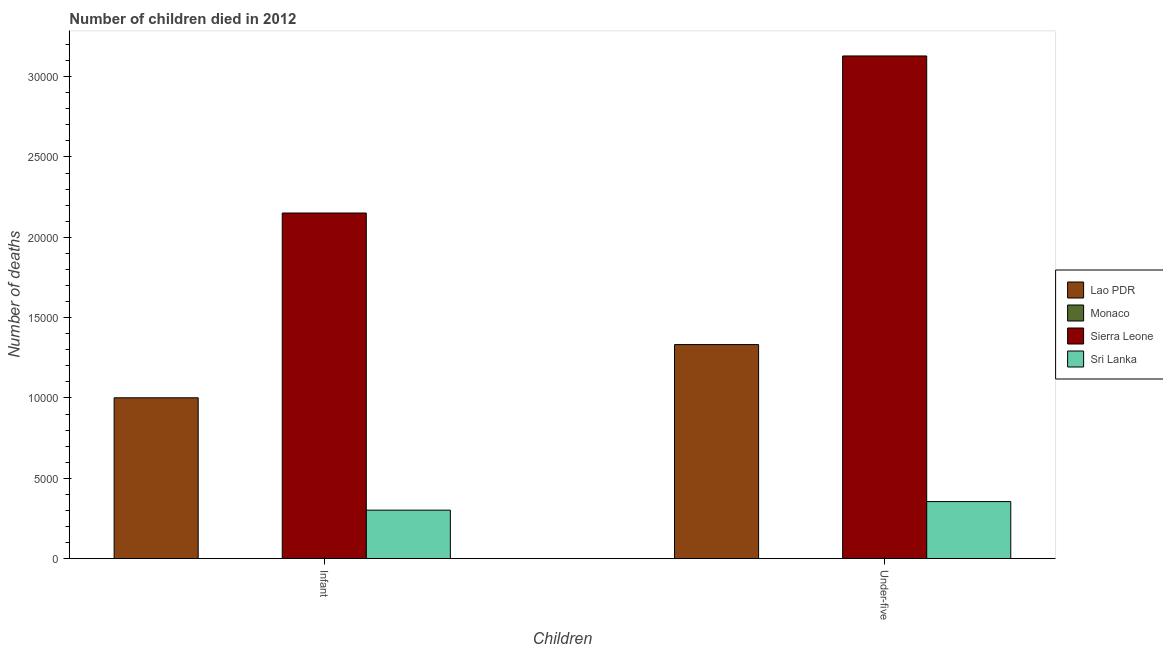How many different coloured bars are there?
Provide a succinct answer. 4. Are the number of bars per tick equal to the number of legend labels?
Offer a very short reply. Yes. How many bars are there on the 2nd tick from the left?
Offer a terse response. 4. How many bars are there on the 1st tick from the right?
Provide a short and direct response. 4. What is the label of the 1st group of bars from the left?
Your answer should be compact. Infant. What is the number of infant deaths in Lao PDR?
Make the answer very short. 1.00e+04. Across all countries, what is the maximum number of under-five deaths?
Ensure brevity in your answer.  3.13e+04. Across all countries, what is the minimum number of infant deaths?
Ensure brevity in your answer.  1. In which country was the number of infant deaths maximum?
Your answer should be compact. Sierra Leone. In which country was the number of under-five deaths minimum?
Keep it short and to the point. Monaco. What is the total number of infant deaths in the graph?
Offer a terse response. 3.45e+04. What is the difference between the number of under-five deaths in Monaco and that in Lao PDR?
Offer a terse response. -1.33e+04. What is the difference between the number of infant deaths in Monaco and the number of under-five deaths in Lao PDR?
Keep it short and to the point. -1.33e+04. What is the average number of under-five deaths per country?
Your answer should be very brief. 1.20e+04. What is the difference between the number of under-five deaths and number of infant deaths in Monaco?
Your answer should be very brief. 0. What is the ratio of the number of under-five deaths in Sierra Leone to that in Lao PDR?
Ensure brevity in your answer.  2.35. In how many countries, is the number of under-five deaths greater than the average number of under-five deaths taken over all countries?
Ensure brevity in your answer.  2. What does the 4th bar from the left in Infant represents?
Your answer should be compact. Sri Lanka. What does the 1st bar from the right in Under-five represents?
Keep it short and to the point. Sri Lanka. How many bars are there?
Your response must be concise. 8. How many countries are there in the graph?
Your response must be concise. 4. How many legend labels are there?
Make the answer very short. 4. What is the title of the graph?
Ensure brevity in your answer.  Number of children died in 2012. What is the label or title of the X-axis?
Offer a terse response. Children. What is the label or title of the Y-axis?
Make the answer very short. Number of deaths. What is the Number of deaths in Lao PDR in Infant?
Ensure brevity in your answer.  1.00e+04. What is the Number of deaths in Sierra Leone in Infant?
Your response must be concise. 2.15e+04. What is the Number of deaths of Sri Lanka in Infant?
Your answer should be very brief. 3014. What is the Number of deaths in Lao PDR in Under-five?
Give a very brief answer. 1.33e+04. What is the Number of deaths of Monaco in Under-five?
Offer a very short reply. 1. What is the Number of deaths of Sierra Leone in Under-five?
Your answer should be very brief. 3.13e+04. What is the Number of deaths of Sri Lanka in Under-five?
Provide a short and direct response. 3547. Across all Children, what is the maximum Number of deaths in Lao PDR?
Keep it short and to the point. 1.33e+04. Across all Children, what is the maximum Number of deaths in Monaco?
Provide a succinct answer. 1. Across all Children, what is the maximum Number of deaths in Sierra Leone?
Provide a succinct answer. 3.13e+04. Across all Children, what is the maximum Number of deaths in Sri Lanka?
Provide a short and direct response. 3547. Across all Children, what is the minimum Number of deaths of Lao PDR?
Your response must be concise. 1.00e+04. Across all Children, what is the minimum Number of deaths of Sierra Leone?
Provide a succinct answer. 2.15e+04. Across all Children, what is the minimum Number of deaths of Sri Lanka?
Offer a very short reply. 3014. What is the total Number of deaths of Lao PDR in the graph?
Keep it short and to the point. 2.33e+04. What is the total Number of deaths in Sierra Leone in the graph?
Your answer should be very brief. 5.28e+04. What is the total Number of deaths in Sri Lanka in the graph?
Your answer should be compact. 6561. What is the difference between the Number of deaths of Lao PDR in Infant and that in Under-five?
Your response must be concise. -3312. What is the difference between the Number of deaths of Sierra Leone in Infant and that in Under-five?
Give a very brief answer. -9778. What is the difference between the Number of deaths in Sri Lanka in Infant and that in Under-five?
Your response must be concise. -533. What is the difference between the Number of deaths in Lao PDR in Infant and the Number of deaths in Monaco in Under-five?
Make the answer very short. 1.00e+04. What is the difference between the Number of deaths of Lao PDR in Infant and the Number of deaths of Sierra Leone in Under-five?
Give a very brief answer. -2.13e+04. What is the difference between the Number of deaths in Lao PDR in Infant and the Number of deaths in Sri Lanka in Under-five?
Offer a very short reply. 6462. What is the difference between the Number of deaths of Monaco in Infant and the Number of deaths of Sierra Leone in Under-five?
Offer a terse response. -3.13e+04. What is the difference between the Number of deaths in Monaco in Infant and the Number of deaths in Sri Lanka in Under-five?
Make the answer very short. -3546. What is the difference between the Number of deaths in Sierra Leone in Infant and the Number of deaths in Sri Lanka in Under-five?
Ensure brevity in your answer.  1.80e+04. What is the average Number of deaths of Lao PDR per Children?
Keep it short and to the point. 1.17e+04. What is the average Number of deaths in Sierra Leone per Children?
Provide a succinct answer. 2.64e+04. What is the average Number of deaths of Sri Lanka per Children?
Offer a very short reply. 3280.5. What is the difference between the Number of deaths in Lao PDR and Number of deaths in Monaco in Infant?
Your answer should be compact. 1.00e+04. What is the difference between the Number of deaths of Lao PDR and Number of deaths of Sierra Leone in Infant?
Provide a succinct answer. -1.15e+04. What is the difference between the Number of deaths in Lao PDR and Number of deaths in Sri Lanka in Infant?
Ensure brevity in your answer.  6995. What is the difference between the Number of deaths of Monaco and Number of deaths of Sierra Leone in Infant?
Give a very brief answer. -2.15e+04. What is the difference between the Number of deaths in Monaco and Number of deaths in Sri Lanka in Infant?
Offer a very short reply. -3013. What is the difference between the Number of deaths in Sierra Leone and Number of deaths in Sri Lanka in Infant?
Offer a terse response. 1.85e+04. What is the difference between the Number of deaths in Lao PDR and Number of deaths in Monaco in Under-five?
Offer a terse response. 1.33e+04. What is the difference between the Number of deaths of Lao PDR and Number of deaths of Sierra Leone in Under-five?
Your answer should be very brief. -1.80e+04. What is the difference between the Number of deaths of Lao PDR and Number of deaths of Sri Lanka in Under-five?
Provide a short and direct response. 9774. What is the difference between the Number of deaths of Monaco and Number of deaths of Sierra Leone in Under-five?
Ensure brevity in your answer.  -3.13e+04. What is the difference between the Number of deaths of Monaco and Number of deaths of Sri Lanka in Under-five?
Give a very brief answer. -3546. What is the difference between the Number of deaths of Sierra Leone and Number of deaths of Sri Lanka in Under-five?
Provide a succinct answer. 2.77e+04. What is the ratio of the Number of deaths in Lao PDR in Infant to that in Under-five?
Provide a short and direct response. 0.75. What is the ratio of the Number of deaths of Monaco in Infant to that in Under-five?
Provide a succinct answer. 1. What is the ratio of the Number of deaths of Sierra Leone in Infant to that in Under-five?
Give a very brief answer. 0.69. What is the ratio of the Number of deaths in Sri Lanka in Infant to that in Under-five?
Your answer should be very brief. 0.85. What is the difference between the highest and the second highest Number of deaths in Lao PDR?
Give a very brief answer. 3312. What is the difference between the highest and the second highest Number of deaths of Monaco?
Offer a terse response. 0. What is the difference between the highest and the second highest Number of deaths in Sierra Leone?
Ensure brevity in your answer.  9778. What is the difference between the highest and the second highest Number of deaths of Sri Lanka?
Your answer should be compact. 533. What is the difference between the highest and the lowest Number of deaths of Lao PDR?
Provide a succinct answer. 3312. What is the difference between the highest and the lowest Number of deaths in Sierra Leone?
Provide a succinct answer. 9778. What is the difference between the highest and the lowest Number of deaths of Sri Lanka?
Offer a terse response. 533. 